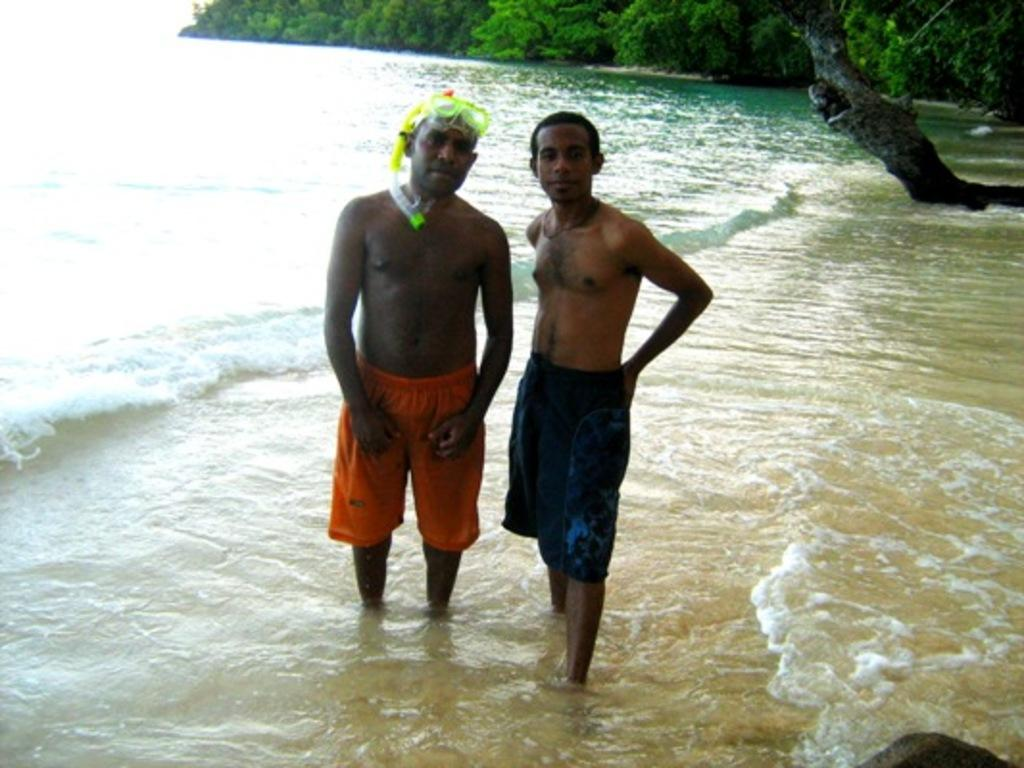What are the two persons in the image doing? The two persons are standing on water in the image. What can be seen in the background of the image? There are trees in the background of the image. What type of balloon is being used to copy the trees in the image? There is no balloon or copying activity present in the image; it features two persons standing on water with trees in the background. 